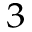<formula> <loc_0><loc_0><loc_500><loc_500>^ { 3 }</formula> 